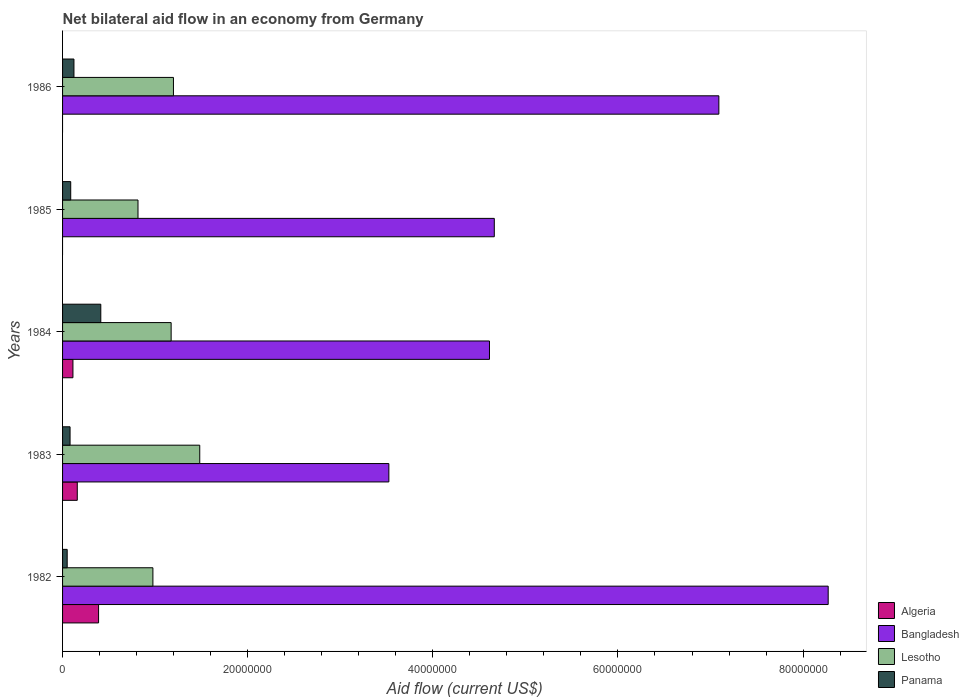How many groups of bars are there?
Make the answer very short. 5. Are the number of bars per tick equal to the number of legend labels?
Your answer should be compact. No. Are the number of bars on each tick of the Y-axis equal?
Give a very brief answer. No. How many bars are there on the 5th tick from the top?
Provide a short and direct response. 4. In how many cases, is the number of bars for a given year not equal to the number of legend labels?
Ensure brevity in your answer.  2. What is the net bilateral aid flow in Bangladesh in 1982?
Ensure brevity in your answer.  8.27e+07. Across all years, what is the maximum net bilateral aid flow in Algeria?
Provide a succinct answer. 3.89e+06. Across all years, what is the minimum net bilateral aid flow in Bangladesh?
Your answer should be compact. 3.52e+07. In which year was the net bilateral aid flow in Algeria maximum?
Provide a succinct answer. 1982. What is the total net bilateral aid flow in Algeria in the graph?
Provide a succinct answer. 6.60e+06. What is the difference between the net bilateral aid flow in Bangladesh in 1984 and that in 1986?
Offer a terse response. -2.48e+07. What is the difference between the net bilateral aid flow in Algeria in 1985 and the net bilateral aid flow in Lesotho in 1986?
Offer a very short reply. -1.20e+07. What is the average net bilateral aid flow in Bangladesh per year?
Provide a succinct answer. 5.63e+07. In the year 1985, what is the difference between the net bilateral aid flow in Panama and net bilateral aid flow in Bangladesh?
Keep it short and to the point. -4.58e+07. What is the ratio of the net bilateral aid flow in Lesotho in 1983 to that in 1984?
Provide a short and direct response. 1.26. Is the net bilateral aid flow in Lesotho in 1985 less than that in 1986?
Your response must be concise. Yes. Is the difference between the net bilateral aid flow in Panama in 1982 and 1985 greater than the difference between the net bilateral aid flow in Bangladesh in 1982 and 1985?
Offer a very short reply. No. What is the difference between the highest and the second highest net bilateral aid flow in Lesotho?
Provide a short and direct response. 2.84e+06. What is the difference between the highest and the lowest net bilateral aid flow in Algeria?
Keep it short and to the point. 3.89e+06. In how many years, is the net bilateral aid flow in Algeria greater than the average net bilateral aid flow in Algeria taken over all years?
Ensure brevity in your answer.  2. Is the sum of the net bilateral aid flow in Panama in 1982 and 1986 greater than the maximum net bilateral aid flow in Bangladesh across all years?
Provide a succinct answer. No. Is it the case that in every year, the sum of the net bilateral aid flow in Panama and net bilateral aid flow in Bangladesh is greater than the net bilateral aid flow in Algeria?
Offer a very short reply. Yes. What is the difference between two consecutive major ticks on the X-axis?
Your answer should be very brief. 2.00e+07. Are the values on the major ticks of X-axis written in scientific E-notation?
Provide a short and direct response. No. Where does the legend appear in the graph?
Keep it short and to the point. Bottom right. How many legend labels are there?
Your response must be concise. 4. How are the legend labels stacked?
Keep it short and to the point. Vertical. What is the title of the graph?
Your answer should be very brief. Net bilateral aid flow in an economy from Germany. What is the Aid flow (current US$) of Algeria in 1982?
Keep it short and to the point. 3.89e+06. What is the Aid flow (current US$) in Bangladesh in 1982?
Your answer should be very brief. 8.27e+07. What is the Aid flow (current US$) in Lesotho in 1982?
Provide a short and direct response. 9.76e+06. What is the Aid flow (current US$) in Panama in 1982?
Provide a short and direct response. 5.00e+05. What is the Aid flow (current US$) in Algeria in 1983?
Offer a very short reply. 1.59e+06. What is the Aid flow (current US$) in Bangladesh in 1983?
Your response must be concise. 3.52e+07. What is the Aid flow (current US$) in Lesotho in 1983?
Give a very brief answer. 1.48e+07. What is the Aid flow (current US$) in Panama in 1983?
Your response must be concise. 8.10e+05. What is the Aid flow (current US$) in Algeria in 1984?
Keep it short and to the point. 1.12e+06. What is the Aid flow (current US$) of Bangladesh in 1984?
Your answer should be compact. 4.61e+07. What is the Aid flow (current US$) in Lesotho in 1984?
Your response must be concise. 1.17e+07. What is the Aid flow (current US$) of Panama in 1984?
Your answer should be compact. 4.13e+06. What is the Aid flow (current US$) in Algeria in 1985?
Provide a succinct answer. 0. What is the Aid flow (current US$) of Bangladesh in 1985?
Your answer should be very brief. 4.66e+07. What is the Aid flow (current US$) of Lesotho in 1985?
Give a very brief answer. 8.15e+06. What is the Aid flow (current US$) of Panama in 1985?
Make the answer very short. 8.80e+05. What is the Aid flow (current US$) in Bangladesh in 1986?
Provide a short and direct response. 7.09e+07. What is the Aid flow (current US$) in Lesotho in 1986?
Your answer should be very brief. 1.20e+07. What is the Aid flow (current US$) in Panama in 1986?
Provide a succinct answer. 1.23e+06. Across all years, what is the maximum Aid flow (current US$) in Algeria?
Your answer should be very brief. 3.89e+06. Across all years, what is the maximum Aid flow (current US$) of Bangladesh?
Ensure brevity in your answer.  8.27e+07. Across all years, what is the maximum Aid flow (current US$) of Lesotho?
Give a very brief answer. 1.48e+07. Across all years, what is the maximum Aid flow (current US$) of Panama?
Your answer should be very brief. 4.13e+06. Across all years, what is the minimum Aid flow (current US$) in Algeria?
Your answer should be very brief. 0. Across all years, what is the minimum Aid flow (current US$) of Bangladesh?
Offer a terse response. 3.52e+07. Across all years, what is the minimum Aid flow (current US$) of Lesotho?
Give a very brief answer. 8.15e+06. What is the total Aid flow (current US$) of Algeria in the graph?
Your answer should be compact. 6.60e+06. What is the total Aid flow (current US$) of Bangladesh in the graph?
Make the answer very short. 2.82e+08. What is the total Aid flow (current US$) of Lesotho in the graph?
Give a very brief answer. 5.64e+07. What is the total Aid flow (current US$) of Panama in the graph?
Ensure brevity in your answer.  7.55e+06. What is the difference between the Aid flow (current US$) of Algeria in 1982 and that in 1983?
Offer a terse response. 2.30e+06. What is the difference between the Aid flow (current US$) in Bangladesh in 1982 and that in 1983?
Keep it short and to the point. 4.75e+07. What is the difference between the Aid flow (current US$) in Lesotho in 1982 and that in 1983?
Keep it short and to the point. -5.06e+06. What is the difference between the Aid flow (current US$) of Panama in 1982 and that in 1983?
Your response must be concise. -3.10e+05. What is the difference between the Aid flow (current US$) in Algeria in 1982 and that in 1984?
Offer a very short reply. 2.77e+06. What is the difference between the Aid flow (current US$) in Bangladesh in 1982 and that in 1984?
Make the answer very short. 3.66e+07. What is the difference between the Aid flow (current US$) in Lesotho in 1982 and that in 1984?
Your answer should be compact. -1.97e+06. What is the difference between the Aid flow (current US$) of Panama in 1982 and that in 1984?
Keep it short and to the point. -3.63e+06. What is the difference between the Aid flow (current US$) in Bangladesh in 1982 and that in 1985?
Your response must be concise. 3.61e+07. What is the difference between the Aid flow (current US$) of Lesotho in 1982 and that in 1985?
Your answer should be compact. 1.61e+06. What is the difference between the Aid flow (current US$) of Panama in 1982 and that in 1985?
Your response must be concise. -3.80e+05. What is the difference between the Aid flow (current US$) of Bangladesh in 1982 and that in 1986?
Give a very brief answer. 1.18e+07. What is the difference between the Aid flow (current US$) of Lesotho in 1982 and that in 1986?
Your answer should be compact. -2.22e+06. What is the difference between the Aid flow (current US$) of Panama in 1982 and that in 1986?
Offer a terse response. -7.30e+05. What is the difference between the Aid flow (current US$) in Algeria in 1983 and that in 1984?
Keep it short and to the point. 4.70e+05. What is the difference between the Aid flow (current US$) of Bangladesh in 1983 and that in 1984?
Offer a terse response. -1.09e+07. What is the difference between the Aid flow (current US$) of Lesotho in 1983 and that in 1984?
Make the answer very short. 3.09e+06. What is the difference between the Aid flow (current US$) in Panama in 1983 and that in 1984?
Provide a short and direct response. -3.32e+06. What is the difference between the Aid flow (current US$) in Bangladesh in 1983 and that in 1985?
Give a very brief answer. -1.14e+07. What is the difference between the Aid flow (current US$) of Lesotho in 1983 and that in 1985?
Your answer should be very brief. 6.67e+06. What is the difference between the Aid flow (current US$) in Bangladesh in 1983 and that in 1986?
Your response must be concise. -3.56e+07. What is the difference between the Aid flow (current US$) of Lesotho in 1983 and that in 1986?
Keep it short and to the point. 2.84e+06. What is the difference between the Aid flow (current US$) in Panama in 1983 and that in 1986?
Keep it short and to the point. -4.20e+05. What is the difference between the Aid flow (current US$) of Bangladesh in 1984 and that in 1985?
Offer a terse response. -5.20e+05. What is the difference between the Aid flow (current US$) in Lesotho in 1984 and that in 1985?
Offer a very short reply. 3.58e+06. What is the difference between the Aid flow (current US$) in Panama in 1984 and that in 1985?
Make the answer very short. 3.25e+06. What is the difference between the Aid flow (current US$) of Bangladesh in 1984 and that in 1986?
Keep it short and to the point. -2.48e+07. What is the difference between the Aid flow (current US$) in Lesotho in 1984 and that in 1986?
Your answer should be compact. -2.50e+05. What is the difference between the Aid flow (current US$) of Panama in 1984 and that in 1986?
Your answer should be very brief. 2.90e+06. What is the difference between the Aid flow (current US$) in Bangladesh in 1985 and that in 1986?
Your answer should be very brief. -2.43e+07. What is the difference between the Aid flow (current US$) of Lesotho in 1985 and that in 1986?
Provide a short and direct response. -3.83e+06. What is the difference between the Aid flow (current US$) in Panama in 1985 and that in 1986?
Your answer should be very brief. -3.50e+05. What is the difference between the Aid flow (current US$) of Algeria in 1982 and the Aid flow (current US$) of Bangladesh in 1983?
Your response must be concise. -3.14e+07. What is the difference between the Aid flow (current US$) of Algeria in 1982 and the Aid flow (current US$) of Lesotho in 1983?
Offer a terse response. -1.09e+07. What is the difference between the Aid flow (current US$) of Algeria in 1982 and the Aid flow (current US$) of Panama in 1983?
Your answer should be very brief. 3.08e+06. What is the difference between the Aid flow (current US$) of Bangladesh in 1982 and the Aid flow (current US$) of Lesotho in 1983?
Keep it short and to the point. 6.79e+07. What is the difference between the Aid flow (current US$) in Bangladesh in 1982 and the Aid flow (current US$) in Panama in 1983?
Provide a short and direct response. 8.19e+07. What is the difference between the Aid flow (current US$) of Lesotho in 1982 and the Aid flow (current US$) of Panama in 1983?
Your answer should be very brief. 8.95e+06. What is the difference between the Aid flow (current US$) of Algeria in 1982 and the Aid flow (current US$) of Bangladesh in 1984?
Provide a succinct answer. -4.22e+07. What is the difference between the Aid flow (current US$) of Algeria in 1982 and the Aid flow (current US$) of Lesotho in 1984?
Your response must be concise. -7.84e+06. What is the difference between the Aid flow (current US$) in Algeria in 1982 and the Aid flow (current US$) in Panama in 1984?
Provide a short and direct response. -2.40e+05. What is the difference between the Aid flow (current US$) of Bangladesh in 1982 and the Aid flow (current US$) of Lesotho in 1984?
Your response must be concise. 7.10e+07. What is the difference between the Aid flow (current US$) of Bangladesh in 1982 and the Aid flow (current US$) of Panama in 1984?
Your answer should be compact. 7.86e+07. What is the difference between the Aid flow (current US$) in Lesotho in 1982 and the Aid flow (current US$) in Panama in 1984?
Your answer should be very brief. 5.63e+06. What is the difference between the Aid flow (current US$) of Algeria in 1982 and the Aid flow (current US$) of Bangladesh in 1985?
Make the answer very short. -4.28e+07. What is the difference between the Aid flow (current US$) of Algeria in 1982 and the Aid flow (current US$) of Lesotho in 1985?
Offer a very short reply. -4.26e+06. What is the difference between the Aid flow (current US$) in Algeria in 1982 and the Aid flow (current US$) in Panama in 1985?
Offer a terse response. 3.01e+06. What is the difference between the Aid flow (current US$) of Bangladesh in 1982 and the Aid flow (current US$) of Lesotho in 1985?
Your answer should be compact. 7.46e+07. What is the difference between the Aid flow (current US$) in Bangladesh in 1982 and the Aid flow (current US$) in Panama in 1985?
Give a very brief answer. 8.18e+07. What is the difference between the Aid flow (current US$) of Lesotho in 1982 and the Aid flow (current US$) of Panama in 1985?
Give a very brief answer. 8.88e+06. What is the difference between the Aid flow (current US$) of Algeria in 1982 and the Aid flow (current US$) of Bangladesh in 1986?
Give a very brief answer. -6.70e+07. What is the difference between the Aid flow (current US$) of Algeria in 1982 and the Aid flow (current US$) of Lesotho in 1986?
Offer a very short reply. -8.09e+06. What is the difference between the Aid flow (current US$) of Algeria in 1982 and the Aid flow (current US$) of Panama in 1986?
Offer a very short reply. 2.66e+06. What is the difference between the Aid flow (current US$) in Bangladesh in 1982 and the Aid flow (current US$) in Lesotho in 1986?
Keep it short and to the point. 7.07e+07. What is the difference between the Aid flow (current US$) in Bangladesh in 1982 and the Aid flow (current US$) in Panama in 1986?
Make the answer very short. 8.15e+07. What is the difference between the Aid flow (current US$) in Lesotho in 1982 and the Aid flow (current US$) in Panama in 1986?
Provide a short and direct response. 8.53e+06. What is the difference between the Aid flow (current US$) in Algeria in 1983 and the Aid flow (current US$) in Bangladesh in 1984?
Provide a succinct answer. -4.45e+07. What is the difference between the Aid flow (current US$) in Algeria in 1983 and the Aid flow (current US$) in Lesotho in 1984?
Offer a very short reply. -1.01e+07. What is the difference between the Aid flow (current US$) in Algeria in 1983 and the Aid flow (current US$) in Panama in 1984?
Ensure brevity in your answer.  -2.54e+06. What is the difference between the Aid flow (current US$) in Bangladesh in 1983 and the Aid flow (current US$) in Lesotho in 1984?
Provide a succinct answer. 2.35e+07. What is the difference between the Aid flow (current US$) in Bangladesh in 1983 and the Aid flow (current US$) in Panama in 1984?
Provide a short and direct response. 3.11e+07. What is the difference between the Aid flow (current US$) of Lesotho in 1983 and the Aid flow (current US$) of Panama in 1984?
Your response must be concise. 1.07e+07. What is the difference between the Aid flow (current US$) in Algeria in 1983 and the Aid flow (current US$) in Bangladesh in 1985?
Make the answer very short. -4.50e+07. What is the difference between the Aid flow (current US$) in Algeria in 1983 and the Aid flow (current US$) in Lesotho in 1985?
Keep it short and to the point. -6.56e+06. What is the difference between the Aid flow (current US$) of Algeria in 1983 and the Aid flow (current US$) of Panama in 1985?
Provide a short and direct response. 7.10e+05. What is the difference between the Aid flow (current US$) of Bangladesh in 1983 and the Aid flow (current US$) of Lesotho in 1985?
Provide a short and direct response. 2.71e+07. What is the difference between the Aid flow (current US$) of Bangladesh in 1983 and the Aid flow (current US$) of Panama in 1985?
Provide a short and direct response. 3.44e+07. What is the difference between the Aid flow (current US$) in Lesotho in 1983 and the Aid flow (current US$) in Panama in 1985?
Make the answer very short. 1.39e+07. What is the difference between the Aid flow (current US$) in Algeria in 1983 and the Aid flow (current US$) in Bangladesh in 1986?
Provide a short and direct response. -6.93e+07. What is the difference between the Aid flow (current US$) in Algeria in 1983 and the Aid flow (current US$) in Lesotho in 1986?
Your answer should be very brief. -1.04e+07. What is the difference between the Aid flow (current US$) in Bangladesh in 1983 and the Aid flow (current US$) in Lesotho in 1986?
Your answer should be very brief. 2.33e+07. What is the difference between the Aid flow (current US$) in Bangladesh in 1983 and the Aid flow (current US$) in Panama in 1986?
Ensure brevity in your answer.  3.40e+07. What is the difference between the Aid flow (current US$) of Lesotho in 1983 and the Aid flow (current US$) of Panama in 1986?
Your answer should be compact. 1.36e+07. What is the difference between the Aid flow (current US$) of Algeria in 1984 and the Aid flow (current US$) of Bangladesh in 1985?
Your response must be concise. -4.55e+07. What is the difference between the Aid flow (current US$) of Algeria in 1984 and the Aid flow (current US$) of Lesotho in 1985?
Offer a very short reply. -7.03e+06. What is the difference between the Aid flow (current US$) in Bangladesh in 1984 and the Aid flow (current US$) in Lesotho in 1985?
Give a very brief answer. 3.80e+07. What is the difference between the Aid flow (current US$) in Bangladesh in 1984 and the Aid flow (current US$) in Panama in 1985?
Your answer should be compact. 4.52e+07. What is the difference between the Aid flow (current US$) in Lesotho in 1984 and the Aid flow (current US$) in Panama in 1985?
Keep it short and to the point. 1.08e+07. What is the difference between the Aid flow (current US$) of Algeria in 1984 and the Aid flow (current US$) of Bangladesh in 1986?
Provide a succinct answer. -6.98e+07. What is the difference between the Aid flow (current US$) in Algeria in 1984 and the Aid flow (current US$) in Lesotho in 1986?
Your response must be concise. -1.09e+07. What is the difference between the Aid flow (current US$) of Algeria in 1984 and the Aid flow (current US$) of Panama in 1986?
Make the answer very short. -1.10e+05. What is the difference between the Aid flow (current US$) in Bangladesh in 1984 and the Aid flow (current US$) in Lesotho in 1986?
Offer a very short reply. 3.41e+07. What is the difference between the Aid flow (current US$) in Bangladesh in 1984 and the Aid flow (current US$) in Panama in 1986?
Provide a succinct answer. 4.49e+07. What is the difference between the Aid flow (current US$) of Lesotho in 1984 and the Aid flow (current US$) of Panama in 1986?
Your answer should be compact. 1.05e+07. What is the difference between the Aid flow (current US$) of Bangladesh in 1985 and the Aid flow (current US$) of Lesotho in 1986?
Provide a short and direct response. 3.47e+07. What is the difference between the Aid flow (current US$) of Bangladesh in 1985 and the Aid flow (current US$) of Panama in 1986?
Offer a very short reply. 4.54e+07. What is the difference between the Aid flow (current US$) of Lesotho in 1985 and the Aid flow (current US$) of Panama in 1986?
Provide a short and direct response. 6.92e+06. What is the average Aid flow (current US$) of Algeria per year?
Provide a succinct answer. 1.32e+06. What is the average Aid flow (current US$) of Bangladesh per year?
Ensure brevity in your answer.  5.63e+07. What is the average Aid flow (current US$) of Lesotho per year?
Your answer should be very brief. 1.13e+07. What is the average Aid flow (current US$) in Panama per year?
Your answer should be very brief. 1.51e+06. In the year 1982, what is the difference between the Aid flow (current US$) in Algeria and Aid flow (current US$) in Bangladesh?
Make the answer very short. -7.88e+07. In the year 1982, what is the difference between the Aid flow (current US$) of Algeria and Aid flow (current US$) of Lesotho?
Provide a succinct answer. -5.87e+06. In the year 1982, what is the difference between the Aid flow (current US$) of Algeria and Aid flow (current US$) of Panama?
Your answer should be very brief. 3.39e+06. In the year 1982, what is the difference between the Aid flow (current US$) of Bangladesh and Aid flow (current US$) of Lesotho?
Make the answer very short. 7.30e+07. In the year 1982, what is the difference between the Aid flow (current US$) in Bangladesh and Aid flow (current US$) in Panama?
Provide a succinct answer. 8.22e+07. In the year 1982, what is the difference between the Aid flow (current US$) of Lesotho and Aid flow (current US$) of Panama?
Your response must be concise. 9.26e+06. In the year 1983, what is the difference between the Aid flow (current US$) of Algeria and Aid flow (current US$) of Bangladesh?
Your response must be concise. -3.37e+07. In the year 1983, what is the difference between the Aid flow (current US$) in Algeria and Aid flow (current US$) in Lesotho?
Provide a short and direct response. -1.32e+07. In the year 1983, what is the difference between the Aid flow (current US$) of Algeria and Aid flow (current US$) of Panama?
Provide a succinct answer. 7.80e+05. In the year 1983, what is the difference between the Aid flow (current US$) in Bangladesh and Aid flow (current US$) in Lesotho?
Provide a short and direct response. 2.04e+07. In the year 1983, what is the difference between the Aid flow (current US$) of Bangladesh and Aid flow (current US$) of Panama?
Keep it short and to the point. 3.44e+07. In the year 1983, what is the difference between the Aid flow (current US$) in Lesotho and Aid flow (current US$) in Panama?
Provide a succinct answer. 1.40e+07. In the year 1984, what is the difference between the Aid flow (current US$) in Algeria and Aid flow (current US$) in Bangladesh?
Provide a short and direct response. -4.50e+07. In the year 1984, what is the difference between the Aid flow (current US$) of Algeria and Aid flow (current US$) of Lesotho?
Keep it short and to the point. -1.06e+07. In the year 1984, what is the difference between the Aid flow (current US$) in Algeria and Aid flow (current US$) in Panama?
Your answer should be compact. -3.01e+06. In the year 1984, what is the difference between the Aid flow (current US$) in Bangladesh and Aid flow (current US$) in Lesotho?
Provide a short and direct response. 3.44e+07. In the year 1984, what is the difference between the Aid flow (current US$) in Bangladesh and Aid flow (current US$) in Panama?
Provide a short and direct response. 4.20e+07. In the year 1984, what is the difference between the Aid flow (current US$) in Lesotho and Aid flow (current US$) in Panama?
Provide a succinct answer. 7.60e+06. In the year 1985, what is the difference between the Aid flow (current US$) of Bangladesh and Aid flow (current US$) of Lesotho?
Provide a short and direct response. 3.85e+07. In the year 1985, what is the difference between the Aid flow (current US$) of Bangladesh and Aid flow (current US$) of Panama?
Offer a very short reply. 4.58e+07. In the year 1985, what is the difference between the Aid flow (current US$) in Lesotho and Aid flow (current US$) in Panama?
Offer a very short reply. 7.27e+06. In the year 1986, what is the difference between the Aid flow (current US$) of Bangladesh and Aid flow (current US$) of Lesotho?
Offer a terse response. 5.89e+07. In the year 1986, what is the difference between the Aid flow (current US$) in Bangladesh and Aid flow (current US$) in Panama?
Give a very brief answer. 6.97e+07. In the year 1986, what is the difference between the Aid flow (current US$) of Lesotho and Aid flow (current US$) of Panama?
Offer a terse response. 1.08e+07. What is the ratio of the Aid flow (current US$) of Algeria in 1982 to that in 1983?
Offer a terse response. 2.45. What is the ratio of the Aid flow (current US$) in Bangladesh in 1982 to that in 1983?
Offer a terse response. 2.35. What is the ratio of the Aid flow (current US$) of Lesotho in 1982 to that in 1983?
Your response must be concise. 0.66. What is the ratio of the Aid flow (current US$) of Panama in 1982 to that in 1983?
Give a very brief answer. 0.62. What is the ratio of the Aid flow (current US$) of Algeria in 1982 to that in 1984?
Keep it short and to the point. 3.47. What is the ratio of the Aid flow (current US$) of Bangladesh in 1982 to that in 1984?
Offer a very short reply. 1.79. What is the ratio of the Aid flow (current US$) of Lesotho in 1982 to that in 1984?
Provide a succinct answer. 0.83. What is the ratio of the Aid flow (current US$) of Panama in 1982 to that in 1984?
Your answer should be compact. 0.12. What is the ratio of the Aid flow (current US$) of Bangladesh in 1982 to that in 1985?
Your answer should be very brief. 1.77. What is the ratio of the Aid flow (current US$) of Lesotho in 1982 to that in 1985?
Offer a terse response. 1.2. What is the ratio of the Aid flow (current US$) in Panama in 1982 to that in 1985?
Your answer should be compact. 0.57. What is the ratio of the Aid flow (current US$) of Bangladesh in 1982 to that in 1986?
Your answer should be compact. 1.17. What is the ratio of the Aid flow (current US$) of Lesotho in 1982 to that in 1986?
Offer a very short reply. 0.81. What is the ratio of the Aid flow (current US$) of Panama in 1982 to that in 1986?
Provide a short and direct response. 0.41. What is the ratio of the Aid flow (current US$) in Algeria in 1983 to that in 1984?
Provide a short and direct response. 1.42. What is the ratio of the Aid flow (current US$) of Bangladesh in 1983 to that in 1984?
Provide a succinct answer. 0.76. What is the ratio of the Aid flow (current US$) in Lesotho in 1983 to that in 1984?
Your answer should be compact. 1.26. What is the ratio of the Aid flow (current US$) in Panama in 1983 to that in 1984?
Provide a succinct answer. 0.2. What is the ratio of the Aid flow (current US$) in Bangladesh in 1983 to that in 1985?
Ensure brevity in your answer.  0.76. What is the ratio of the Aid flow (current US$) in Lesotho in 1983 to that in 1985?
Keep it short and to the point. 1.82. What is the ratio of the Aid flow (current US$) of Panama in 1983 to that in 1985?
Your answer should be compact. 0.92. What is the ratio of the Aid flow (current US$) of Bangladesh in 1983 to that in 1986?
Offer a terse response. 0.5. What is the ratio of the Aid flow (current US$) of Lesotho in 1983 to that in 1986?
Give a very brief answer. 1.24. What is the ratio of the Aid flow (current US$) in Panama in 1983 to that in 1986?
Make the answer very short. 0.66. What is the ratio of the Aid flow (current US$) of Bangladesh in 1984 to that in 1985?
Give a very brief answer. 0.99. What is the ratio of the Aid flow (current US$) of Lesotho in 1984 to that in 1985?
Ensure brevity in your answer.  1.44. What is the ratio of the Aid flow (current US$) of Panama in 1984 to that in 1985?
Offer a terse response. 4.69. What is the ratio of the Aid flow (current US$) of Bangladesh in 1984 to that in 1986?
Your answer should be compact. 0.65. What is the ratio of the Aid flow (current US$) in Lesotho in 1984 to that in 1986?
Offer a terse response. 0.98. What is the ratio of the Aid flow (current US$) of Panama in 1984 to that in 1986?
Keep it short and to the point. 3.36. What is the ratio of the Aid flow (current US$) in Bangladesh in 1985 to that in 1986?
Make the answer very short. 0.66. What is the ratio of the Aid flow (current US$) in Lesotho in 1985 to that in 1986?
Make the answer very short. 0.68. What is the ratio of the Aid flow (current US$) in Panama in 1985 to that in 1986?
Offer a terse response. 0.72. What is the difference between the highest and the second highest Aid flow (current US$) in Algeria?
Provide a short and direct response. 2.30e+06. What is the difference between the highest and the second highest Aid flow (current US$) in Bangladesh?
Your answer should be very brief. 1.18e+07. What is the difference between the highest and the second highest Aid flow (current US$) of Lesotho?
Provide a succinct answer. 2.84e+06. What is the difference between the highest and the second highest Aid flow (current US$) of Panama?
Keep it short and to the point. 2.90e+06. What is the difference between the highest and the lowest Aid flow (current US$) of Algeria?
Offer a very short reply. 3.89e+06. What is the difference between the highest and the lowest Aid flow (current US$) of Bangladesh?
Your answer should be very brief. 4.75e+07. What is the difference between the highest and the lowest Aid flow (current US$) in Lesotho?
Provide a short and direct response. 6.67e+06. What is the difference between the highest and the lowest Aid flow (current US$) in Panama?
Provide a short and direct response. 3.63e+06. 